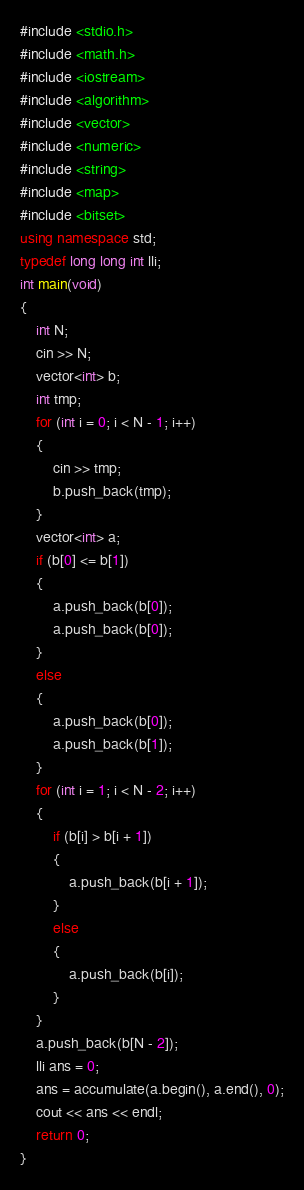<code> <loc_0><loc_0><loc_500><loc_500><_C++_>#include <stdio.h>
#include <math.h>
#include <iostream>
#include <algorithm>
#include <vector>
#include <numeric>
#include <string>
#include <map>
#include <bitset>
using namespace std;
typedef long long int lli;
int main(void)
{
    int N;
    cin >> N;
    vector<int> b;
    int tmp;
    for (int i = 0; i < N - 1; i++)
    {
        cin >> tmp;
        b.push_back(tmp);
    }
    vector<int> a;
    if (b[0] <= b[1])
    {
        a.push_back(b[0]);
        a.push_back(b[0]);
    }
    else
    {
        a.push_back(b[0]);
        a.push_back(b[1]);
    }
    for (int i = 1; i < N - 2; i++)
    {
        if (b[i] > b[i + 1])
        {
            a.push_back(b[i + 1]);
        }
        else
        {
            a.push_back(b[i]);
        }
    }
    a.push_back(b[N - 2]);
    lli ans = 0;
    ans = accumulate(a.begin(), a.end(), 0);
    cout << ans << endl;
    return 0;
}</code> 